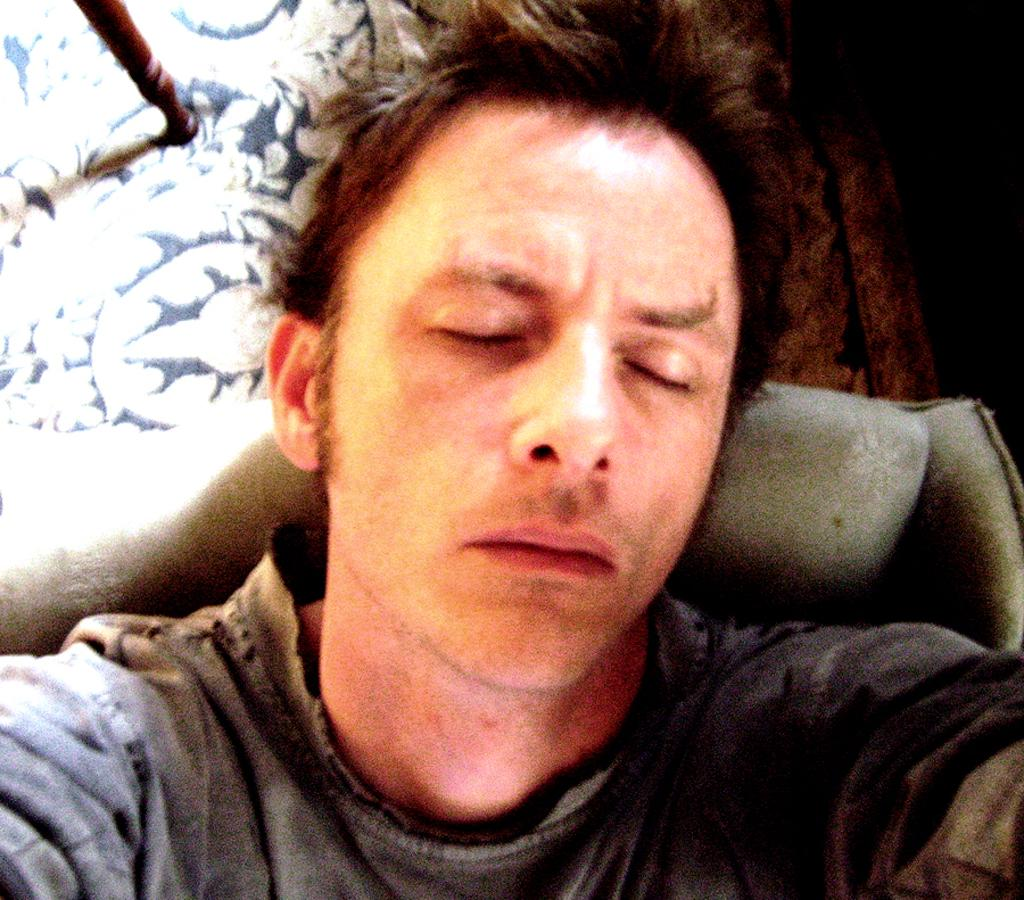Who is present in the image? There is a man in the image. What is the man doing in the image? The man is sleeping. What is the man wearing in the image? The man is wearing a t-shirt. What can be seen on the left side of the image? There is a cloth with flower designs on the left side of the image. What date is circled on the calendar in the image? There is no calendar present in the image. How many women are visible in the image? There are no women visible in the image; only a man is present. What type of jam is being spread on the bread in the image? There is no bread or jam present in the image. 